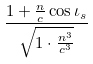Convert formula to latex. <formula><loc_0><loc_0><loc_500><loc_500>\frac { 1 + \frac { n } { c } \cos \iota _ { s } } { \sqrt { 1 \cdot \frac { n ^ { 3 } } { c ^ { 3 } } } }</formula> 